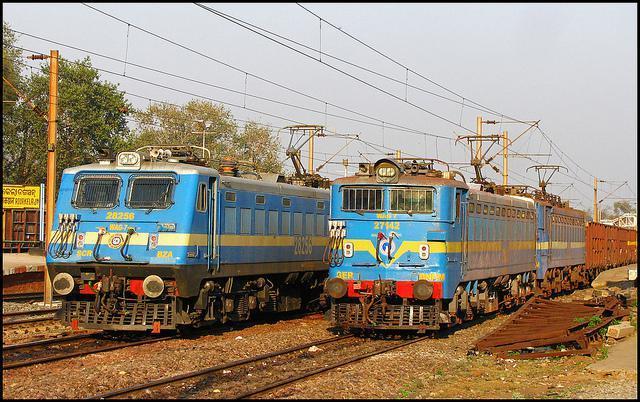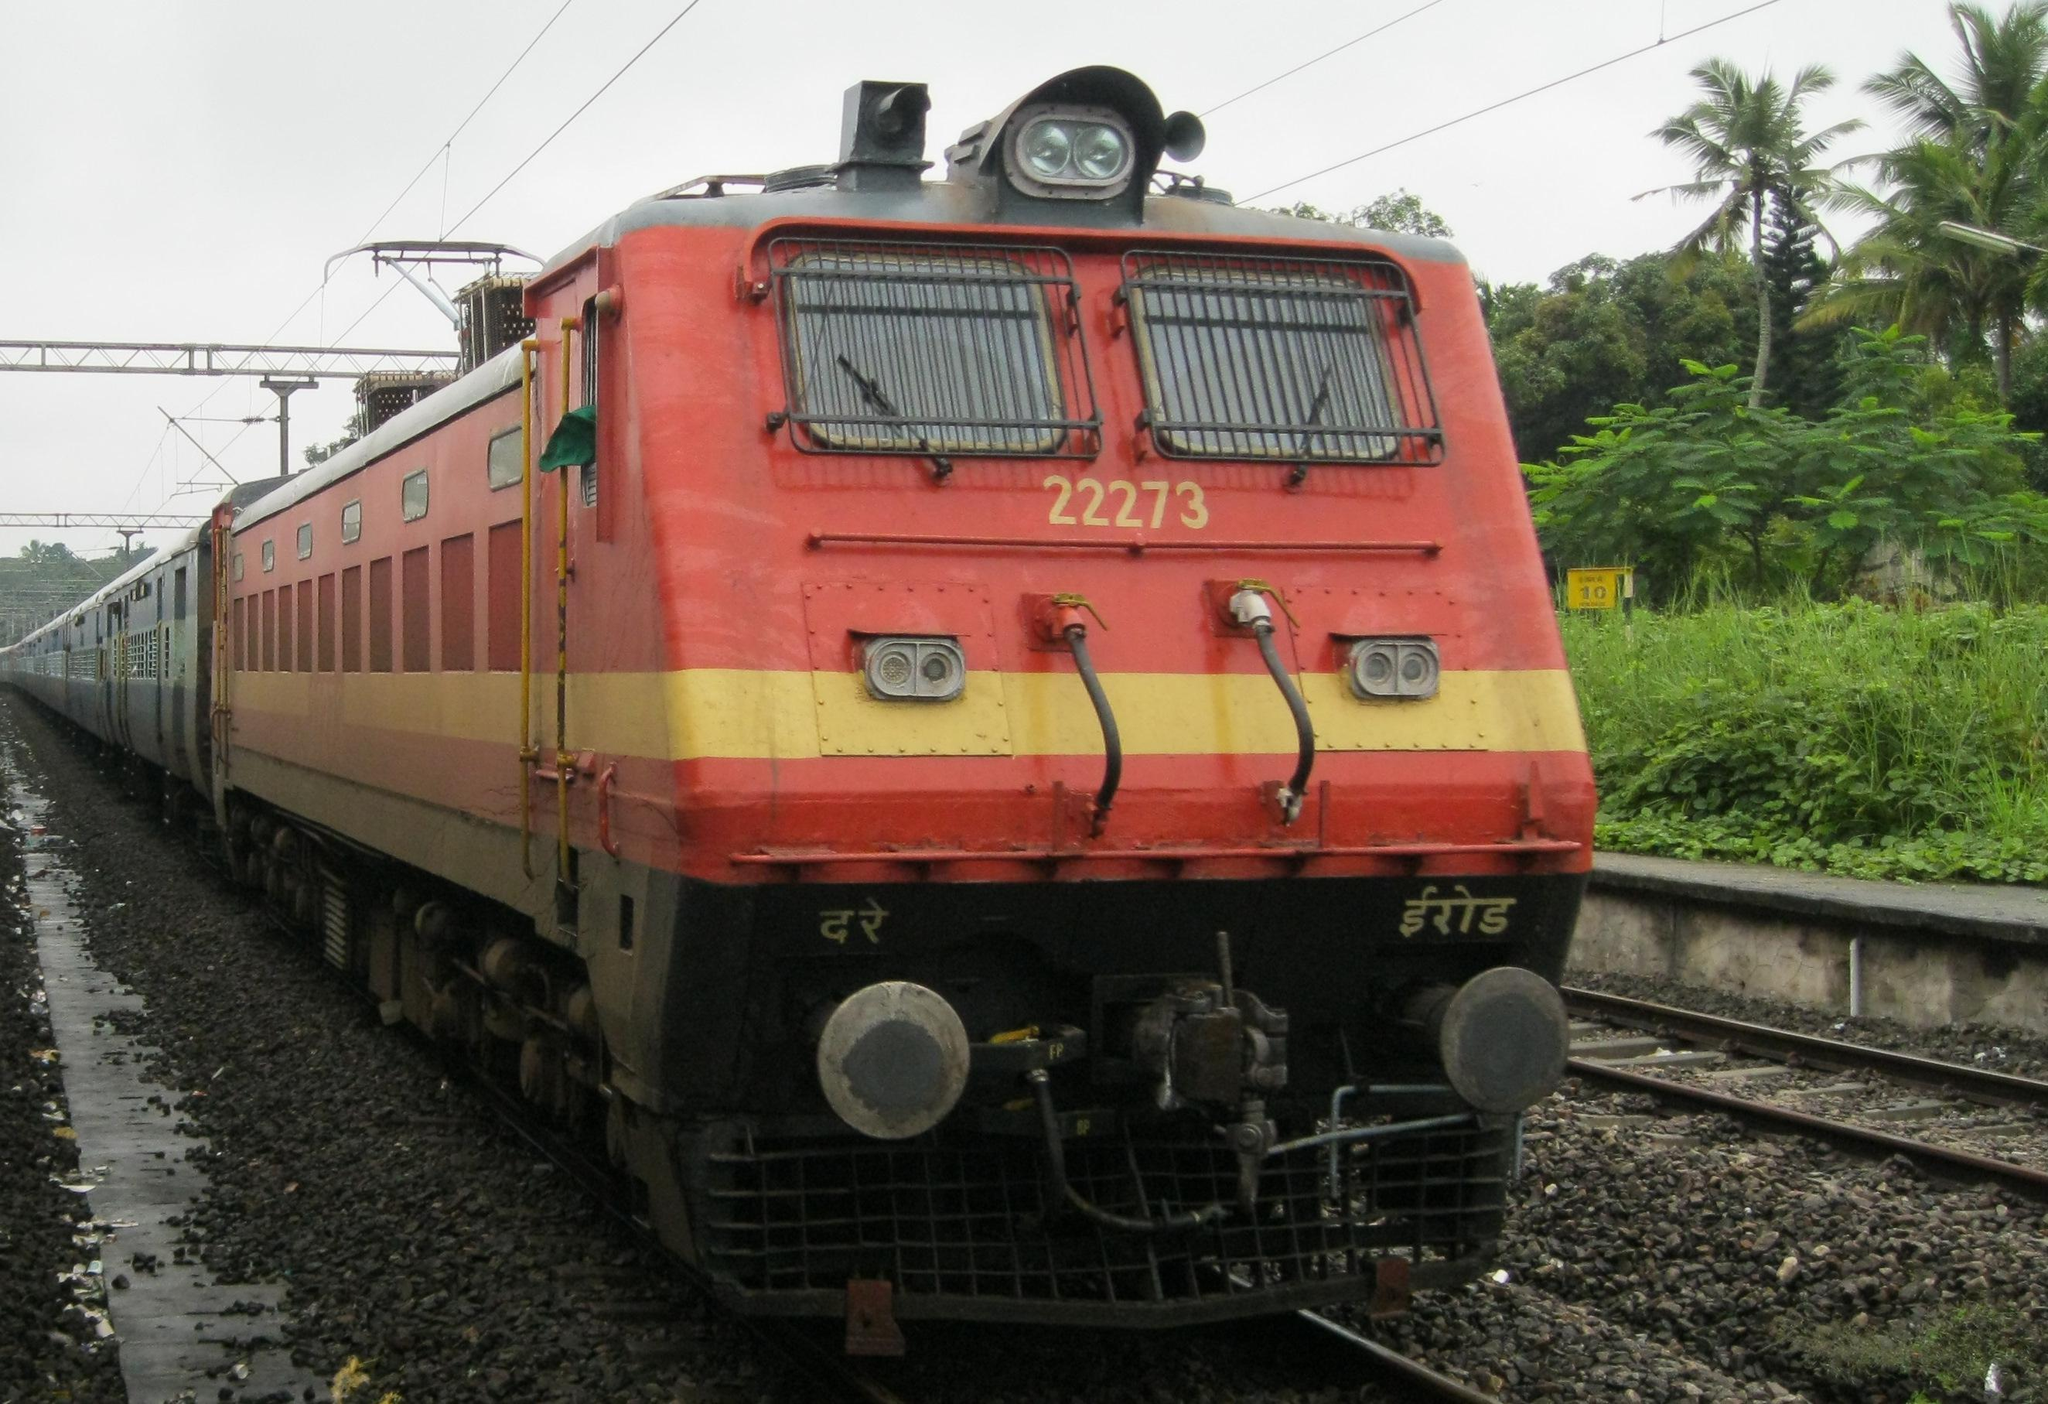The first image is the image on the left, the second image is the image on the right. Assess this claim about the two images: "There are two trains in one of the images.". Correct or not? Answer yes or no. Yes. 